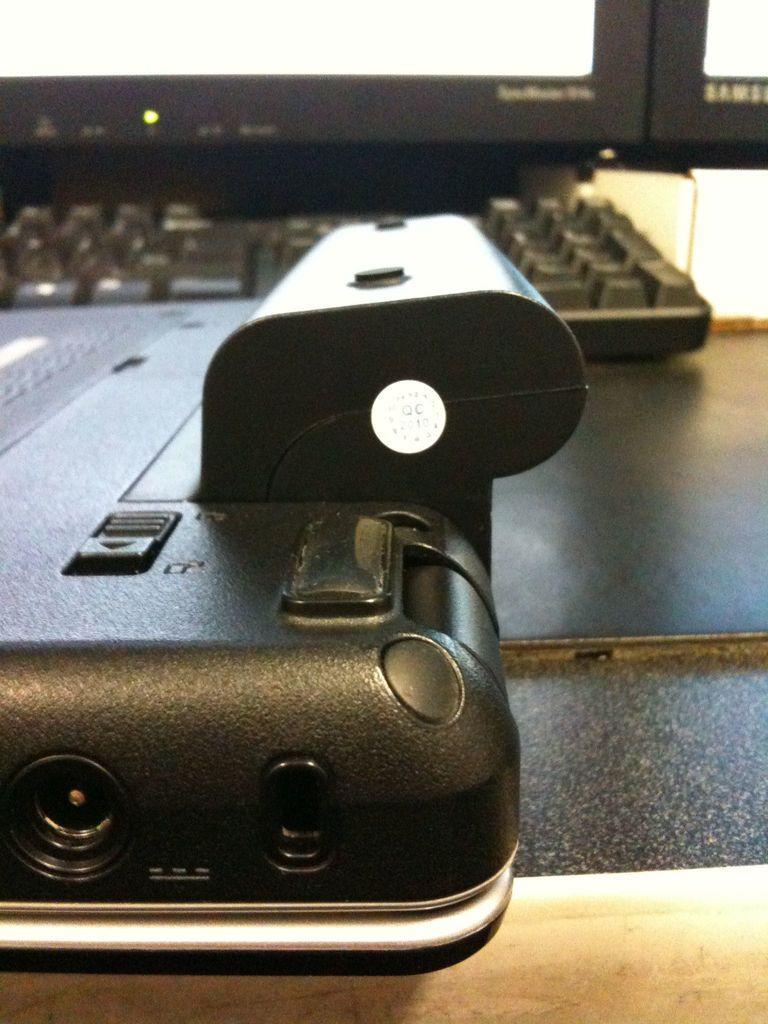Could you give a brief overview of what you see in this image? In this image we can see a table on which there are objects. There is a keyboard. 